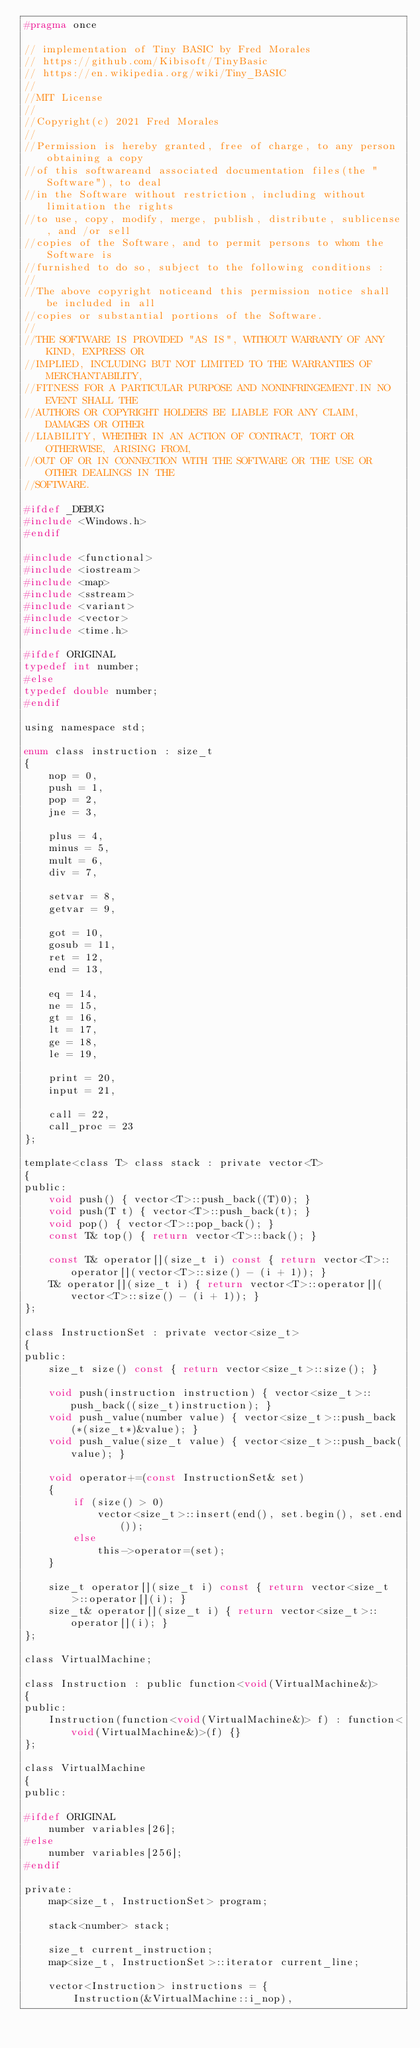<code> <loc_0><loc_0><loc_500><loc_500><_C_>#pragma once

// implementation of Tiny BASIC by Fred Morales
// https://github.com/Kibisoft/TinyBasic
// https://en.wikipedia.org/wiki/Tiny_BASIC
//
//MIT License
//
//Copyright(c) 2021 Fred Morales
//
//Permission is hereby granted, free of charge, to any person obtaining a copy
//of this softwareand associated documentation files(the "Software"), to deal
//in the Software without restriction, including without limitation the rights
//to use, copy, modify, merge, publish, distribute, sublicense, and /or sell
//copies of the Software, and to permit persons to whom the Software is
//furnished to do so, subject to the following conditions :
//
//The above copyright noticeand this permission notice shall be included in all
//copies or substantial portions of the Software.
//
//THE SOFTWARE IS PROVIDED "AS IS", WITHOUT WARRANTY OF ANY KIND, EXPRESS OR
//IMPLIED, INCLUDING BUT NOT LIMITED TO THE WARRANTIES OF MERCHANTABILITY,
//FITNESS FOR A PARTICULAR PURPOSE AND NONINFRINGEMENT.IN NO EVENT SHALL THE
//AUTHORS OR COPYRIGHT HOLDERS BE LIABLE FOR ANY CLAIM, DAMAGES OR OTHER
//LIABILITY, WHETHER IN AN ACTION OF CONTRACT, TORT OR OTHERWISE, ARISING FROM,
//OUT OF OR IN CONNECTION WITH THE SOFTWARE OR THE USE OR OTHER DEALINGS IN THE
//SOFTWARE.

#ifdef _DEBUG
#include <Windows.h>
#endif

#include <functional>
#include <iostream>
#include <map>
#include <sstream>
#include <variant>
#include <vector>
#include <time.h>

#ifdef ORIGINAL
typedef int number;
#else
typedef double number;
#endif

using namespace std;

enum class instruction : size_t
{
    nop = 0,
    push = 1,
    pop = 2,
    jne = 3,

    plus = 4,
    minus = 5,
    mult = 6,
    div = 7,

    setvar = 8,
    getvar = 9,

    got = 10,
    gosub = 11,
    ret = 12,
    end = 13,

    eq = 14,
    ne = 15,
    gt = 16,
    lt = 17,
    ge = 18,
    le = 19,

    print = 20,
    input = 21,

    call = 22,
    call_proc = 23
};

template<class T> class stack : private vector<T>
{
public:
    void push() { vector<T>::push_back((T)0); }
    void push(T t) { vector<T>::push_back(t); }
    void pop() { vector<T>::pop_back(); }
    const T& top() { return vector<T>::back(); }

    const T& operator[](size_t i) const { return vector<T>::operator[](vector<T>::size() - (i + 1)); }
    T& operator[](size_t i) { return vector<T>::operator[](vector<T>::size() - (i + 1)); }
};

class InstructionSet : private vector<size_t>
{
public:
    size_t size() const { return vector<size_t>::size(); }

    void push(instruction instruction) { vector<size_t>::push_back((size_t)instruction); }
    void push_value(number value) { vector<size_t>::push_back(*(size_t*)&value); }
    void push_value(size_t value) { vector<size_t>::push_back(value); }

    void operator+=(const InstructionSet& set)
    {
        if (size() > 0)
            vector<size_t>::insert(end(), set.begin(), set.end());
        else
            this->operator=(set);
    }

    size_t operator[](size_t i) const { return vector<size_t>::operator[](i); }
    size_t& operator[](size_t i) { return vector<size_t>::operator[](i); }
};

class VirtualMachine;

class Instruction : public function<void(VirtualMachine&)>
{
public:
    Instruction(function<void(VirtualMachine&)> f) : function<void(VirtualMachine&)>(f) {}
};

class VirtualMachine
{
public:

#ifdef ORIGINAL
    number variables[26];
#else
    number variables[256];
#endif

private:
    map<size_t, InstructionSet> program;

    stack<number> stack;

    size_t current_instruction;
    map<size_t, InstructionSet>::iterator current_line;

    vector<Instruction> instructions = {
        Instruction(&VirtualMachine::i_nop),</code> 